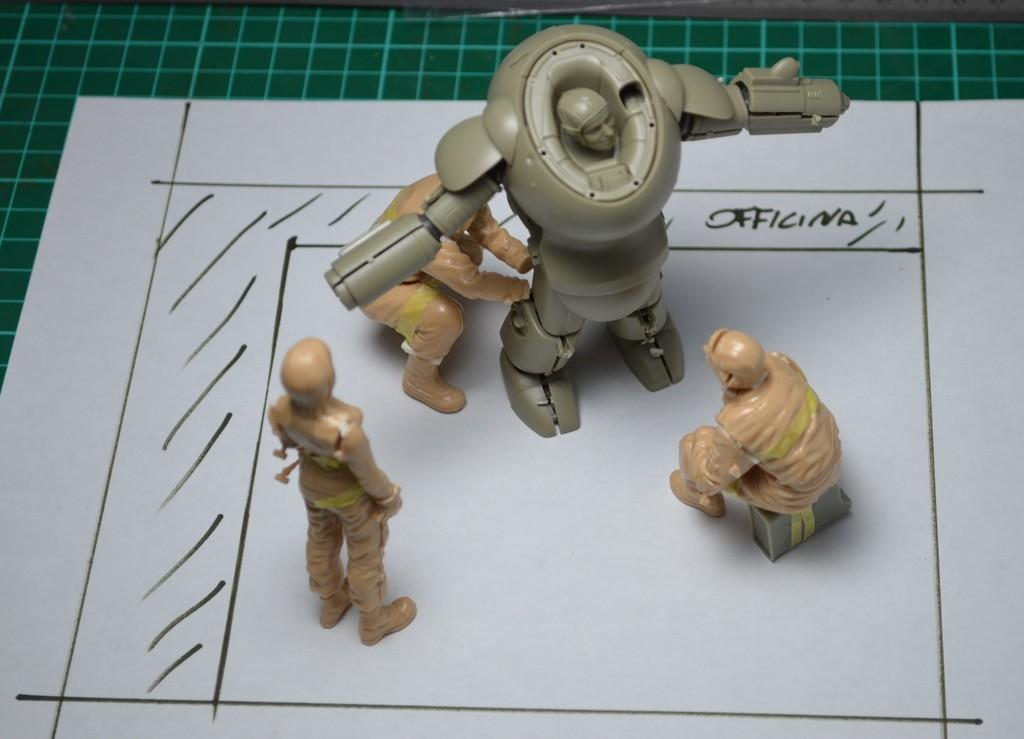What objects can be seen in the image? There are toys in the image. What is the color of the paper on which the toys are placed? The paper is white in color. Are there any words or letters on the paper? Yes, there is writing on the paper. What is the color of the surface beneath the paper? The surface beneath the paper is green in color. Can you describe the crook that is holding the toys in the image? There is no crook present in the image; the toys are simply placed on the white paper. How many roses can be seen in the image? There are no roses present in the image; it features toys on a white paper with writing on it. 